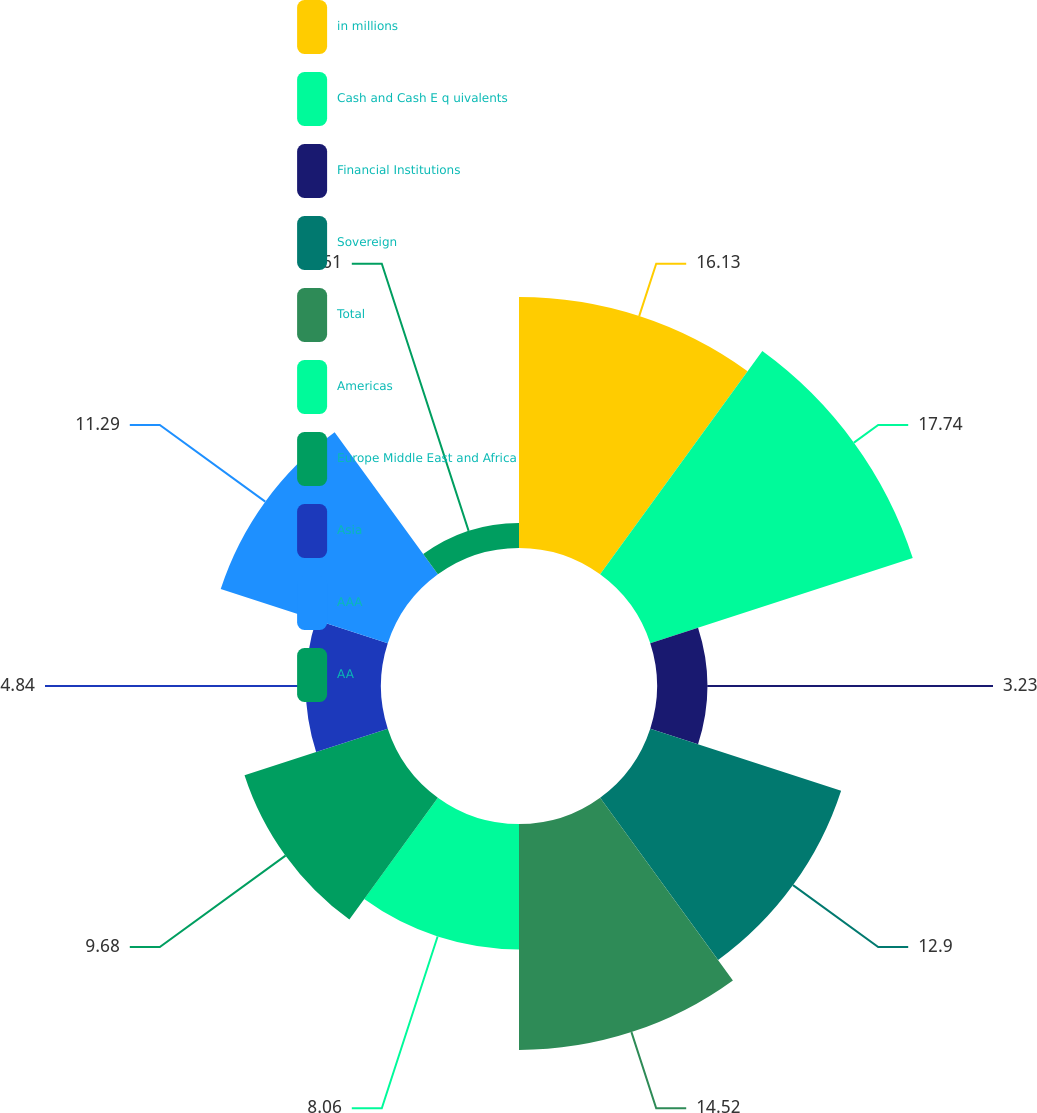Convert chart to OTSL. <chart><loc_0><loc_0><loc_500><loc_500><pie_chart><fcel>in millions<fcel>Cash and Cash E q uivalents<fcel>Financial Institutions<fcel>Sovereign<fcel>Total<fcel>Americas<fcel>Europe Middle East and Africa<fcel>Asia<fcel>AAA<fcel>AA<nl><fcel>16.13%<fcel>17.74%<fcel>3.23%<fcel>12.9%<fcel>14.52%<fcel>8.06%<fcel>9.68%<fcel>4.84%<fcel>11.29%<fcel>1.61%<nl></chart> 